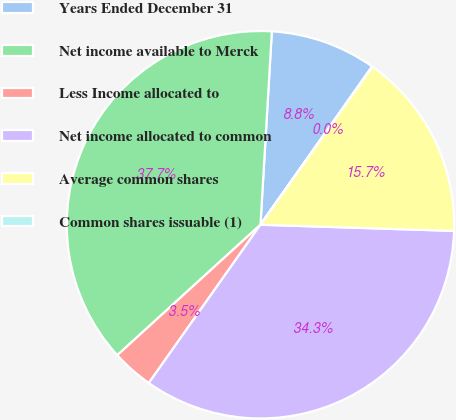<chart> <loc_0><loc_0><loc_500><loc_500><pie_chart><fcel>Years Ended December 31<fcel>Net income available to Merck<fcel>Less Income allocated to<fcel>Net income allocated to common<fcel>Average common shares<fcel>Common shares issuable (1)<nl><fcel>8.84%<fcel>37.7%<fcel>3.46%<fcel>34.27%<fcel>15.7%<fcel>0.03%<nl></chart> 